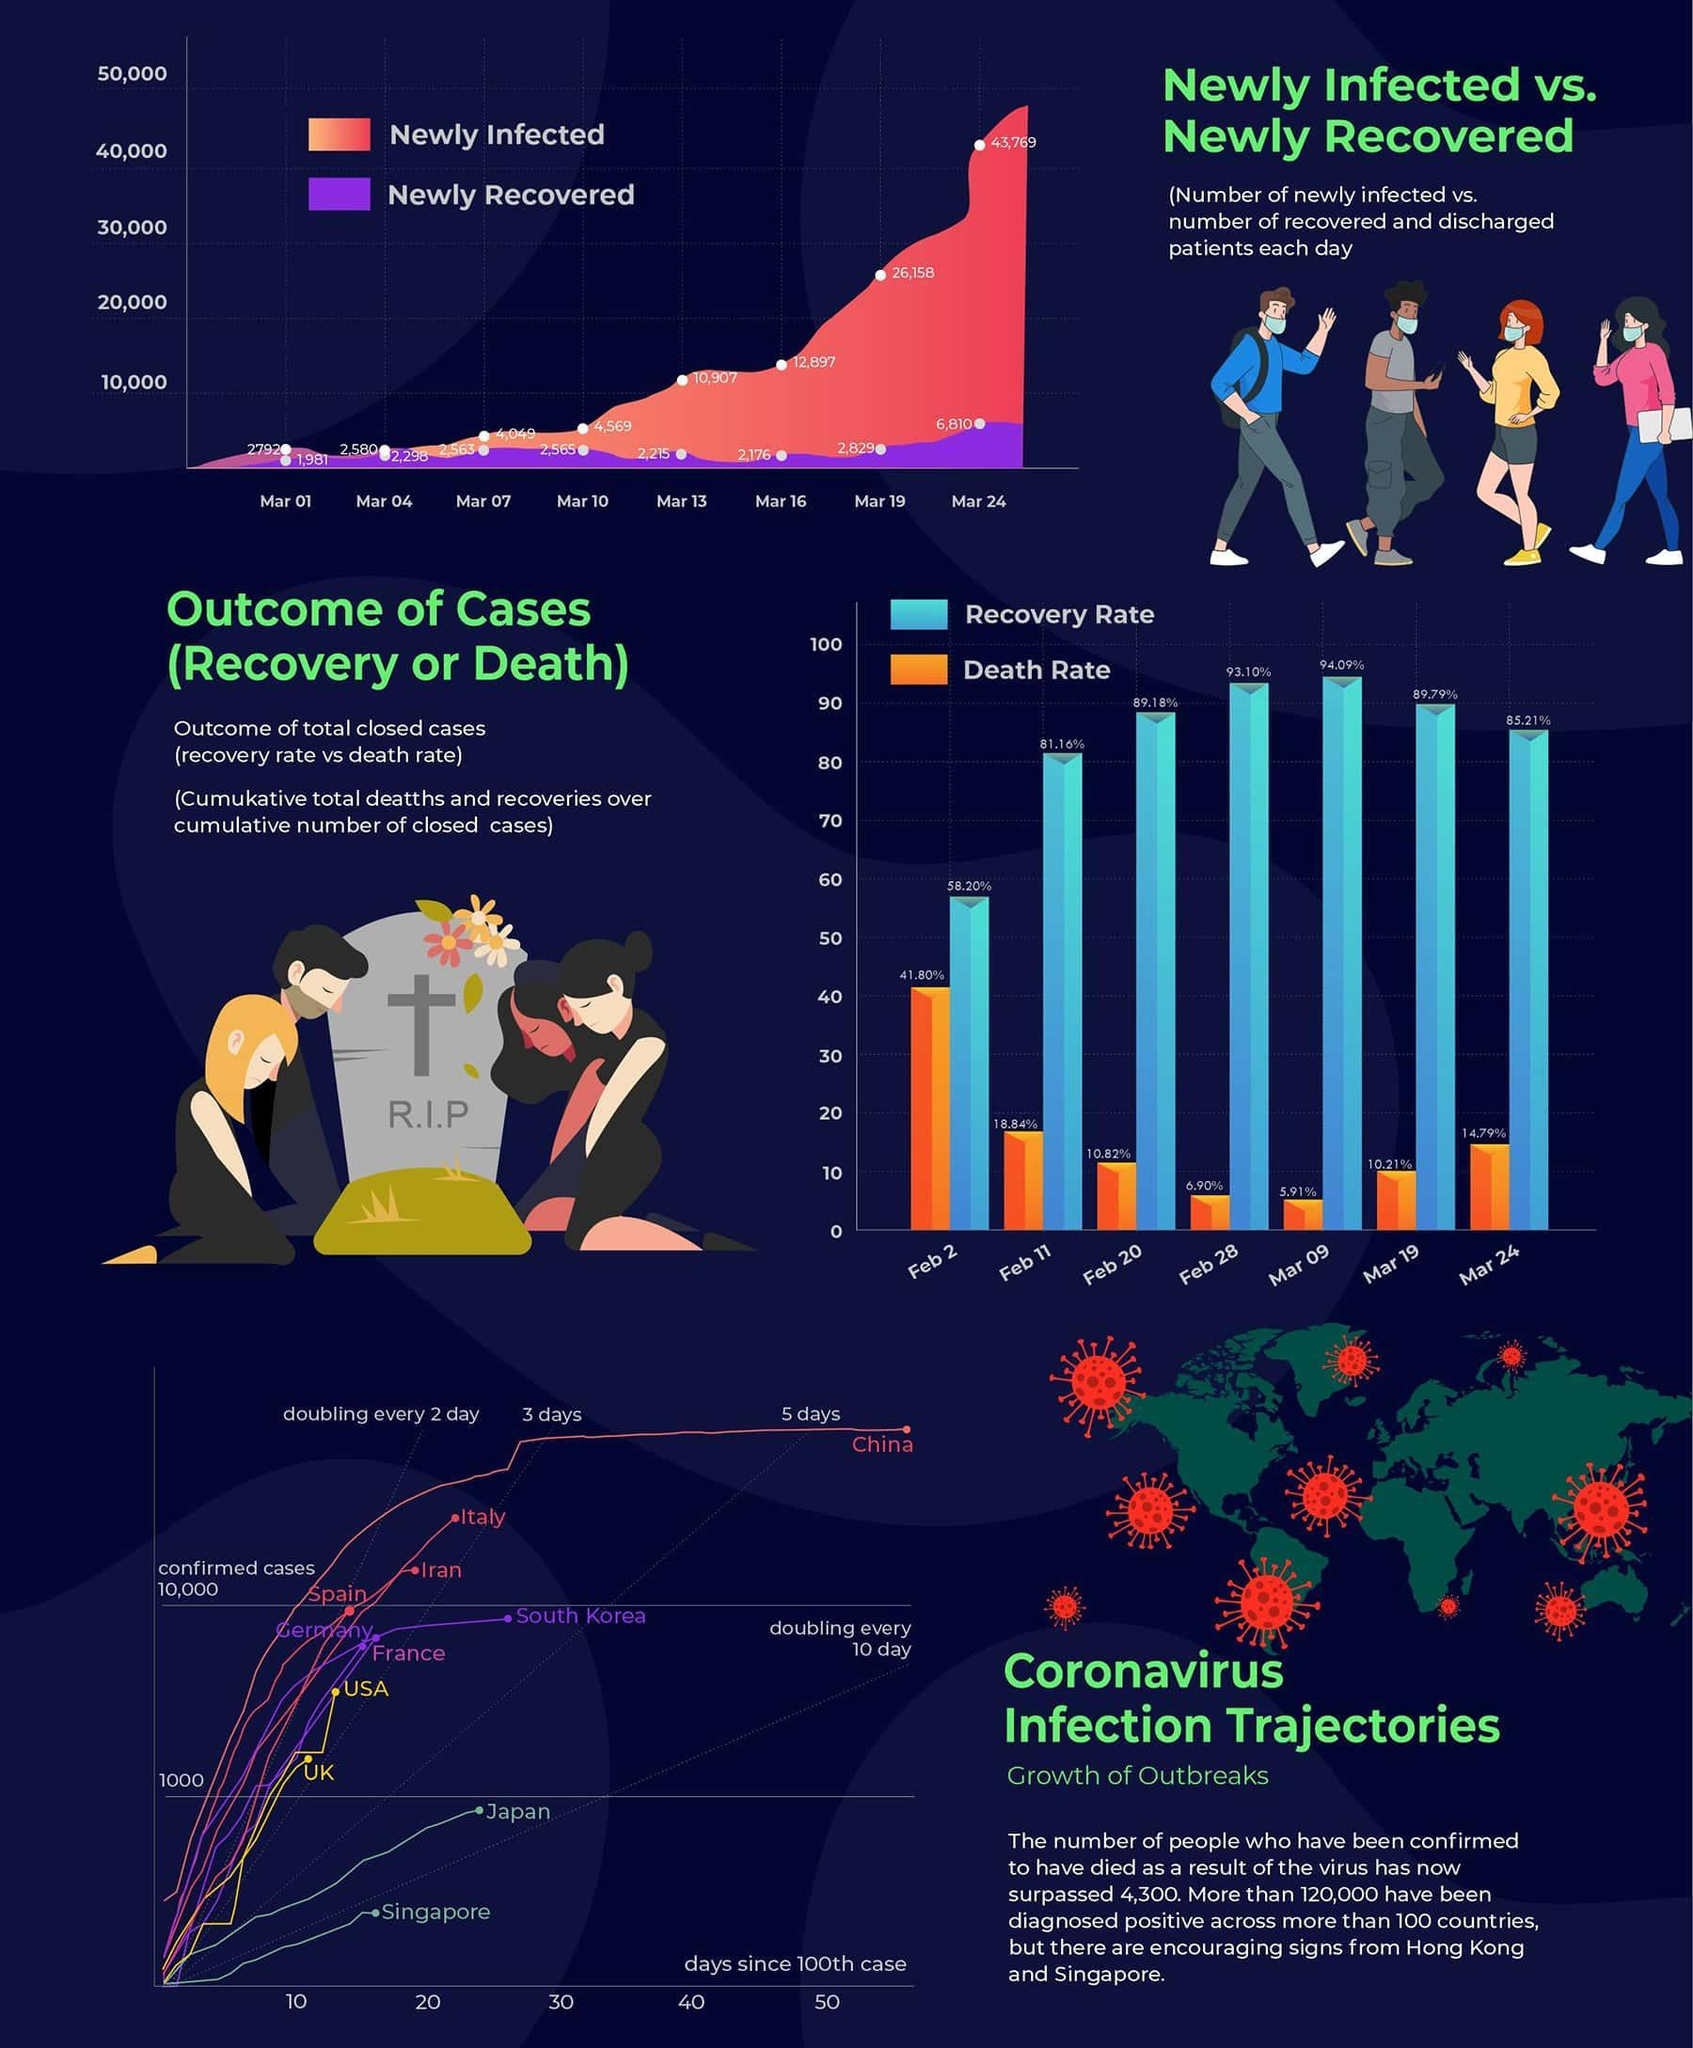What is the number of new COVID-19 cases reported globally on March 19?
Answer the question with a short phrase. 26,158 What is the recovery rate of COVID-19 cases on February 11? 81.16% What is the number of new COVID-19 cases reported globally on March 07? 4,049 What is the recovery rate of COVID-19 cases on March 24? 85.21% How many newly recovered cases of COVID-19 were reported on March 13 globally? 2,215 What is the death rate due to Covid-19 on March 19? 10.21% What is the death rate due to Covid-19 on February 28? 6.90% How many newly recovered cases of COVID-19 were reported on March 24 globally? 6,810 